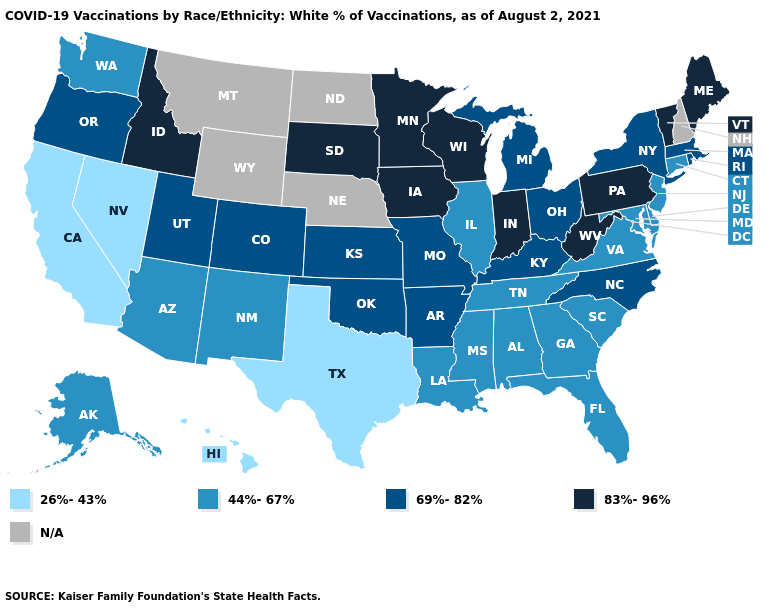Is the legend a continuous bar?
Short answer required. No. Among the states that border Oklahoma , which have the lowest value?
Be succinct. Texas. What is the highest value in the Northeast ?
Short answer required. 83%-96%. What is the value of New York?
Answer briefly. 69%-82%. Name the states that have a value in the range 26%-43%?
Quick response, please. California, Hawaii, Nevada, Texas. What is the value of South Dakota?
Short answer required. 83%-96%. Which states hav the highest value in the MidWest?
Quick response, please. Indiana, Iowa, Minnesota, South Dakota, Wisconsin. Among the states that border Nebraska , does Kansas have the lowest value?
Short answer required. Yes. Does the first symbol in the legend represent the smallest category?
Concise answer only. Yes. What is the highest value in states that border New Mexico?
Give a very brief answer. 69%-82%. Among the states that border Indiana , does Kentucky have the highest value?
Answer briefly. Yes. Does North Carolina have the lowest value in the South?
Concise answer only. No. What is the value of Tennessee?
Give a very brief answer. 44%-67%. What is the value of Wisconsin?
Be succinct. 83%-96%. 